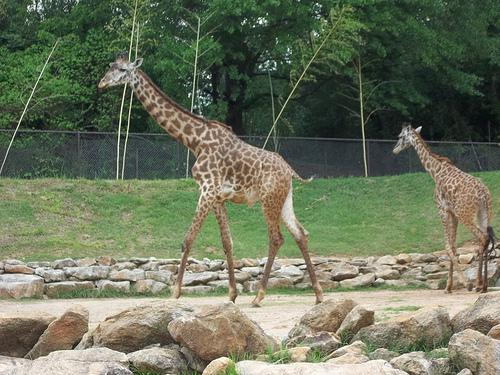Question: how many giraffes are there?
Choices:
A. Two.
B. One.
C. Three.
D. Four.
Answer with the letter. Answer: A Question: why is there a fence?
Choices:
A. For the sheep.
B. For the dogs.
C. To contain the giraffes.
D. For the cows.
Answer with the letter. Answer: C Question: what time of day is it?
Choices:
A. Noon.
B. Dusk.
C. Sunset.
D. Morning.
Answer with the letter. Answer: D Question: where was this taken?
Choices:
A. Bus station.
B. At a zoo.
C. Airport.
D. Forest.
Answer with the letter. Answer: B Question: where are the giraffes?
Choices:
A. In a zoo.
B. On the savanna.
C. By a tree.
D. In water.
Answer with the letter. Answer: A 